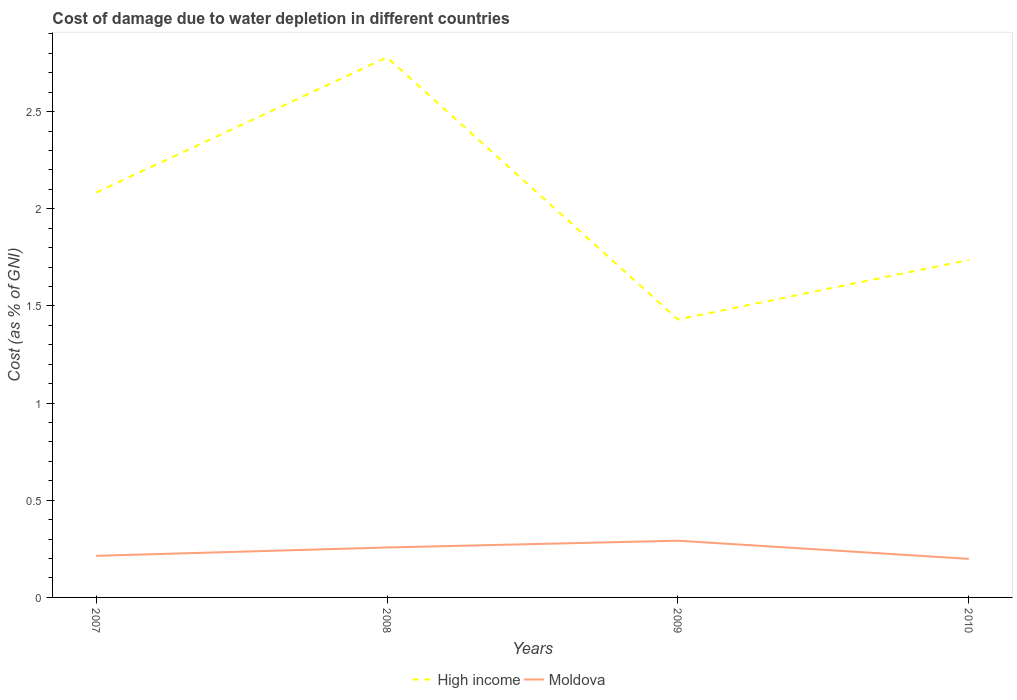How many different coloured lines are there?
Keep it short and to the point. 2. Does the line corresponding to Moldova intersect with the line corresponding to High income?
Offer a very short reply. No. Across all years, what is the maximum cost of damage caused due to water depletion in Moldova?
Provide a succinct answer. 0.2. In which year was the cost of damage caused due to water depletion in Moldova maximum?
Offer a very short reply. 2010. What is the total cost of damage caused due to water depletion in High income in the graph?
Give a very brief answer. -0.31. What is the difference between the highest and the second highest cost of damage caused due to water depletion in Moldova?
Provide a short and direct response. 0.09. What is the difference between the highest and the lowest cost of damage caused due to water depletion in High income?
Keep it short and to the point. 2. Does the graph contain grids?
Offer a very short reply. No. What is the title of the graph?
Your response must be concise. Cost of damage due to water depletion in different countries. What is the label or title of the Y-axis?
Offer a terse response. Cost (as % of GNI). What is the Cost (as % of GNI) in High income in 2007?
Keep it short and to the point. 2.08. What is the Cost (as % of GNI) of Moldova in 2007?
Give a very brief answer. 0.21. What is the Cost (as % of GNI) of High income in 2008?
Offer a terse response. 2.78. What is the Cost (as % of GNI) of Moldova in 2008?
Offer a very short reply. 0.26. What is the Cost (as % of GNI) in High income in 2009?
Provide a succinct answer. 1.43. What is the Cost (as % of GNI) in Moldova in 2009?
Your answer should be compact. 0.29. What is the Cost (as % of GNI) in High income in 2010?
Your answer should be very brief. 1.74. What is the Cost (as % of GNI) in Moldova in 2010?
Your answer should be very brief. 0.2. Across all years, what is the maximum Cost (as % of GNI) of High income?
Offer a very short reply. 2.78. Across all years, what is the maximum Cost (as % of GNI) of Moldova?
Keep it short and to the point. 0.29. Across all years, what is the minimum Cost (as % of GNI) in High income?
Ensure brevity in your answer.  1.43. Across all years, what is the minimum Cost (as % of GNI) in Moldova?
Provide a short and direct response. 0.2. What is the total Cost (as % of GNI) of High income in the graph?
Provide a short and direct response. 8.03. What is the total Cost (as % of GNI) of Moldova in the graph?
Offer a terse response. 0.96. What is the difference between the Cost (as % of GNI) of High income in 2007 and that in 2008?
Provide a short and direct response. -0.7. What is the difference between the Cost (as % of GNI) of Moldova in 2007 and that in 2008?
Keep it short and to the point. -0.04. What is the difference between the Cost (as % of GNI) of High income in 2007 and that in 2009?
Make the answer very short. 0.65. What is the difference between the Cost (as % of GNI) of Moldova in 2007 and that in 2009?
Give a very brief answer. -0.08. What is the difference between the Cost (as % of GNI) in High income in 2007 and that in 2010?
Your answer should be very brief. 0.35. What is the difference between the Cost (as % of GNI) in Moldova in 2007 and that in 2010?
Offer a very short reply. 0.02. What is the difference between the Cost (as % of GNI) of High income in 2008 and that in 2009?
Give a very brief answer. 1.35. What is the difference between the Cost (as % of GNI) of Moldova in 2008 and that in 2009?
Keep it short and to the point. -0.03. What is the difference between the Cost (as % of GNI) in High income in 2008 and that in 2010?
Keep it short and to the point. 1.04. What is the difference between the Cost (as % of GNI) in Moldova in 2008 and that in 2010?
Your answer should be very brief. 0.06. What is the difference between the Cost (as % of GNI) of High income in 2009 and that in 2010?
Keep it short and to the point. -0.31. What is the difference between the Cost (as % of GNI) in Moldova in 2009 and that in 2010?
Ensure brevity in your answer.  0.09. What is the difference between the Cost (as % of GNI) of High income in 2007 and the Cost (as % of GNI) of Moldova in 2008?
Offer a terse response. 1.83. What is the difference between the Cost (as % of GNI) of High income in 2007 and the Cost (as % of GNI) of Moldova in 2009?
Your answer should be compact. 1.79. What is the difference between the Cost (as % of GNI) of High income in 2007 and the Cost (as % of GNI) of Moldova in 2010?
Make the answer very short. 1.89. What is the difference between the Cost (as % of GNI) of High income in 2008 and the Cost (as % of GNI) of Moldova in 2009?
Offer a very short reply. 2.49. What is the difference between the Cost (as % of GNI) in High income in 2008 and the Cost (as % of GNI) in Moldova in 2010?
Offer a very short reply. 2.58. What is the difference between the Cost (as % of GNI) of High income in 2009 and the Cost (as % of GNI) of Moldova in 2010?
Ensure brevity in your answer.  1.23. What is the average Cost (as % of GNI) of High income per year?
Offer a very short reply. 2.01. What is the average Cost (as % of GNI) in Moldova per year?
Your answer should be compact. 0.24. In the year 2007, what is the difference between the Cost (as % of GNI) of High income and Cost (as % of GNI) of Moldova?
Offer a terse response. 1.87. In the year 2008, what is the difference between the Cost (as % of GNI) of High income and Cost (as % of GNI) of Moldova?
Your answer should be compact. 2.52. In the year 2009, what is the difference between the Cost (as % of GNI) in High income and Cost (as % of GNI) in Moldova?
Offer a very short reply. 1.14. In the year 2010, what is the difference between the Cost (as % of GNI) of High income and Cost (as % of GNI) of Moldova?
Keep it short and to the point. 1.54. What is the ratio of the Cost (as % of GNI) in High income in 2007 to that in 2008?
Provide a succinct answer. 0.75. What is the ratio of the Cost (as % of GNI) of Moldova in 2007 to that in 2008?
Offer a terse response. 0.83. What is the ratio of the Cost (as % of GNI) in High income in 2007 to that in 2009?
Offer a terse response. 1.46. What is the ratio of the Cost (as % of GNI) in Moldova in 2007 to that in 2009?
Provide a short and direct response. 0.73. What is the ratio of the Cost (as % of GNI) in High income in 2007 to that in 2010?
Your answer should be very brief. 1.2. What is the ratio of the Cost (as % of GNI) in Moldova in 2007 to that in 2010?
Make the answer very short. 1.08. What is the ratio of the Cost (as % of GNI) of High income in 2008 to that in 2009?
Make the answer very short. 1.94. What is the ratio of the Cost (as % of GNI) of Moldova in 2008 to that in 2009?
Give a very brief answer. 0.88. What is the ratio of the Cost (as % of GNI) in High income in 2008 to that in 2010?
Your response must be concise. 1.6. What is the ratio of the Cost (as % of GNI) in Moldova in 2008 to that in 2010?
Provide a succinct answer. 1.29. What is the ratio of the Cost (as % of GNI) in High income in 2009 to that in 2010?
Your answer should be compact. 0.82. What is the ratio of the Cost (as % of GNI) of Moldova in 2009 to that in 2010?
Offer a terse response. 1.47. What is the difference between the highest and the second highest Cost (as % of GNI) of High income?
Keep it short and to the point. 0.7. What is the difference between the highest and the second highest Cost (as % of GNI) of Moldova?
Your answer should be compact. 0.03. What is the difference between the highest and the lowest Cost (as % of GNI) of High income?
Keep it short and to the point. 1.35. What is the difference between the highest and the lowest Cost (as % of GNI) of Moldova?
Your response must be concise. 0.09. 